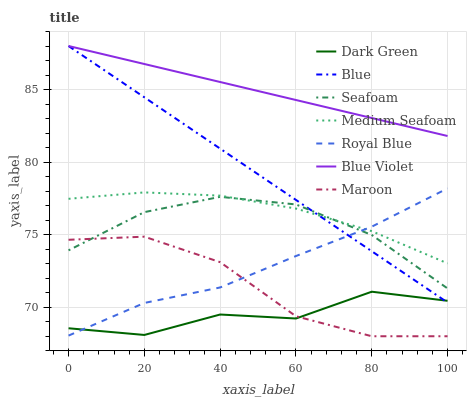Does Dark Green have the minimum area under the curve?
Answer yes or no. Yes. Does Blue Violet have the maximum area under the curve?
Answer yes or no. Yes. Does Seafoam have the minimum area under the curve?
Answer yes or no. No. Does Seafoam have the maximum area under the curve?
Answer yes or no. No. Is Blue Violet the smoothest?
Answer yes or no. Yes. Is Dark Green the roughest?
Answer yes or no. Yes. Is Seafoam the smoothest?
Answer yes or no. No. Is Seafoam the roughest?
Answer yes or no. No. Does Seafoam have the lowest value?
Answer yes or no. No. Does Seafoam have the highest value?
Answer yes or no. No. Is Maroon less than Blue?
Answer yes or no. Yes. Is Blue Violet greater than Maroon?
Answer yes or no. Yes. Does Maroon intersect Blue?
Answer yes or no. No. 